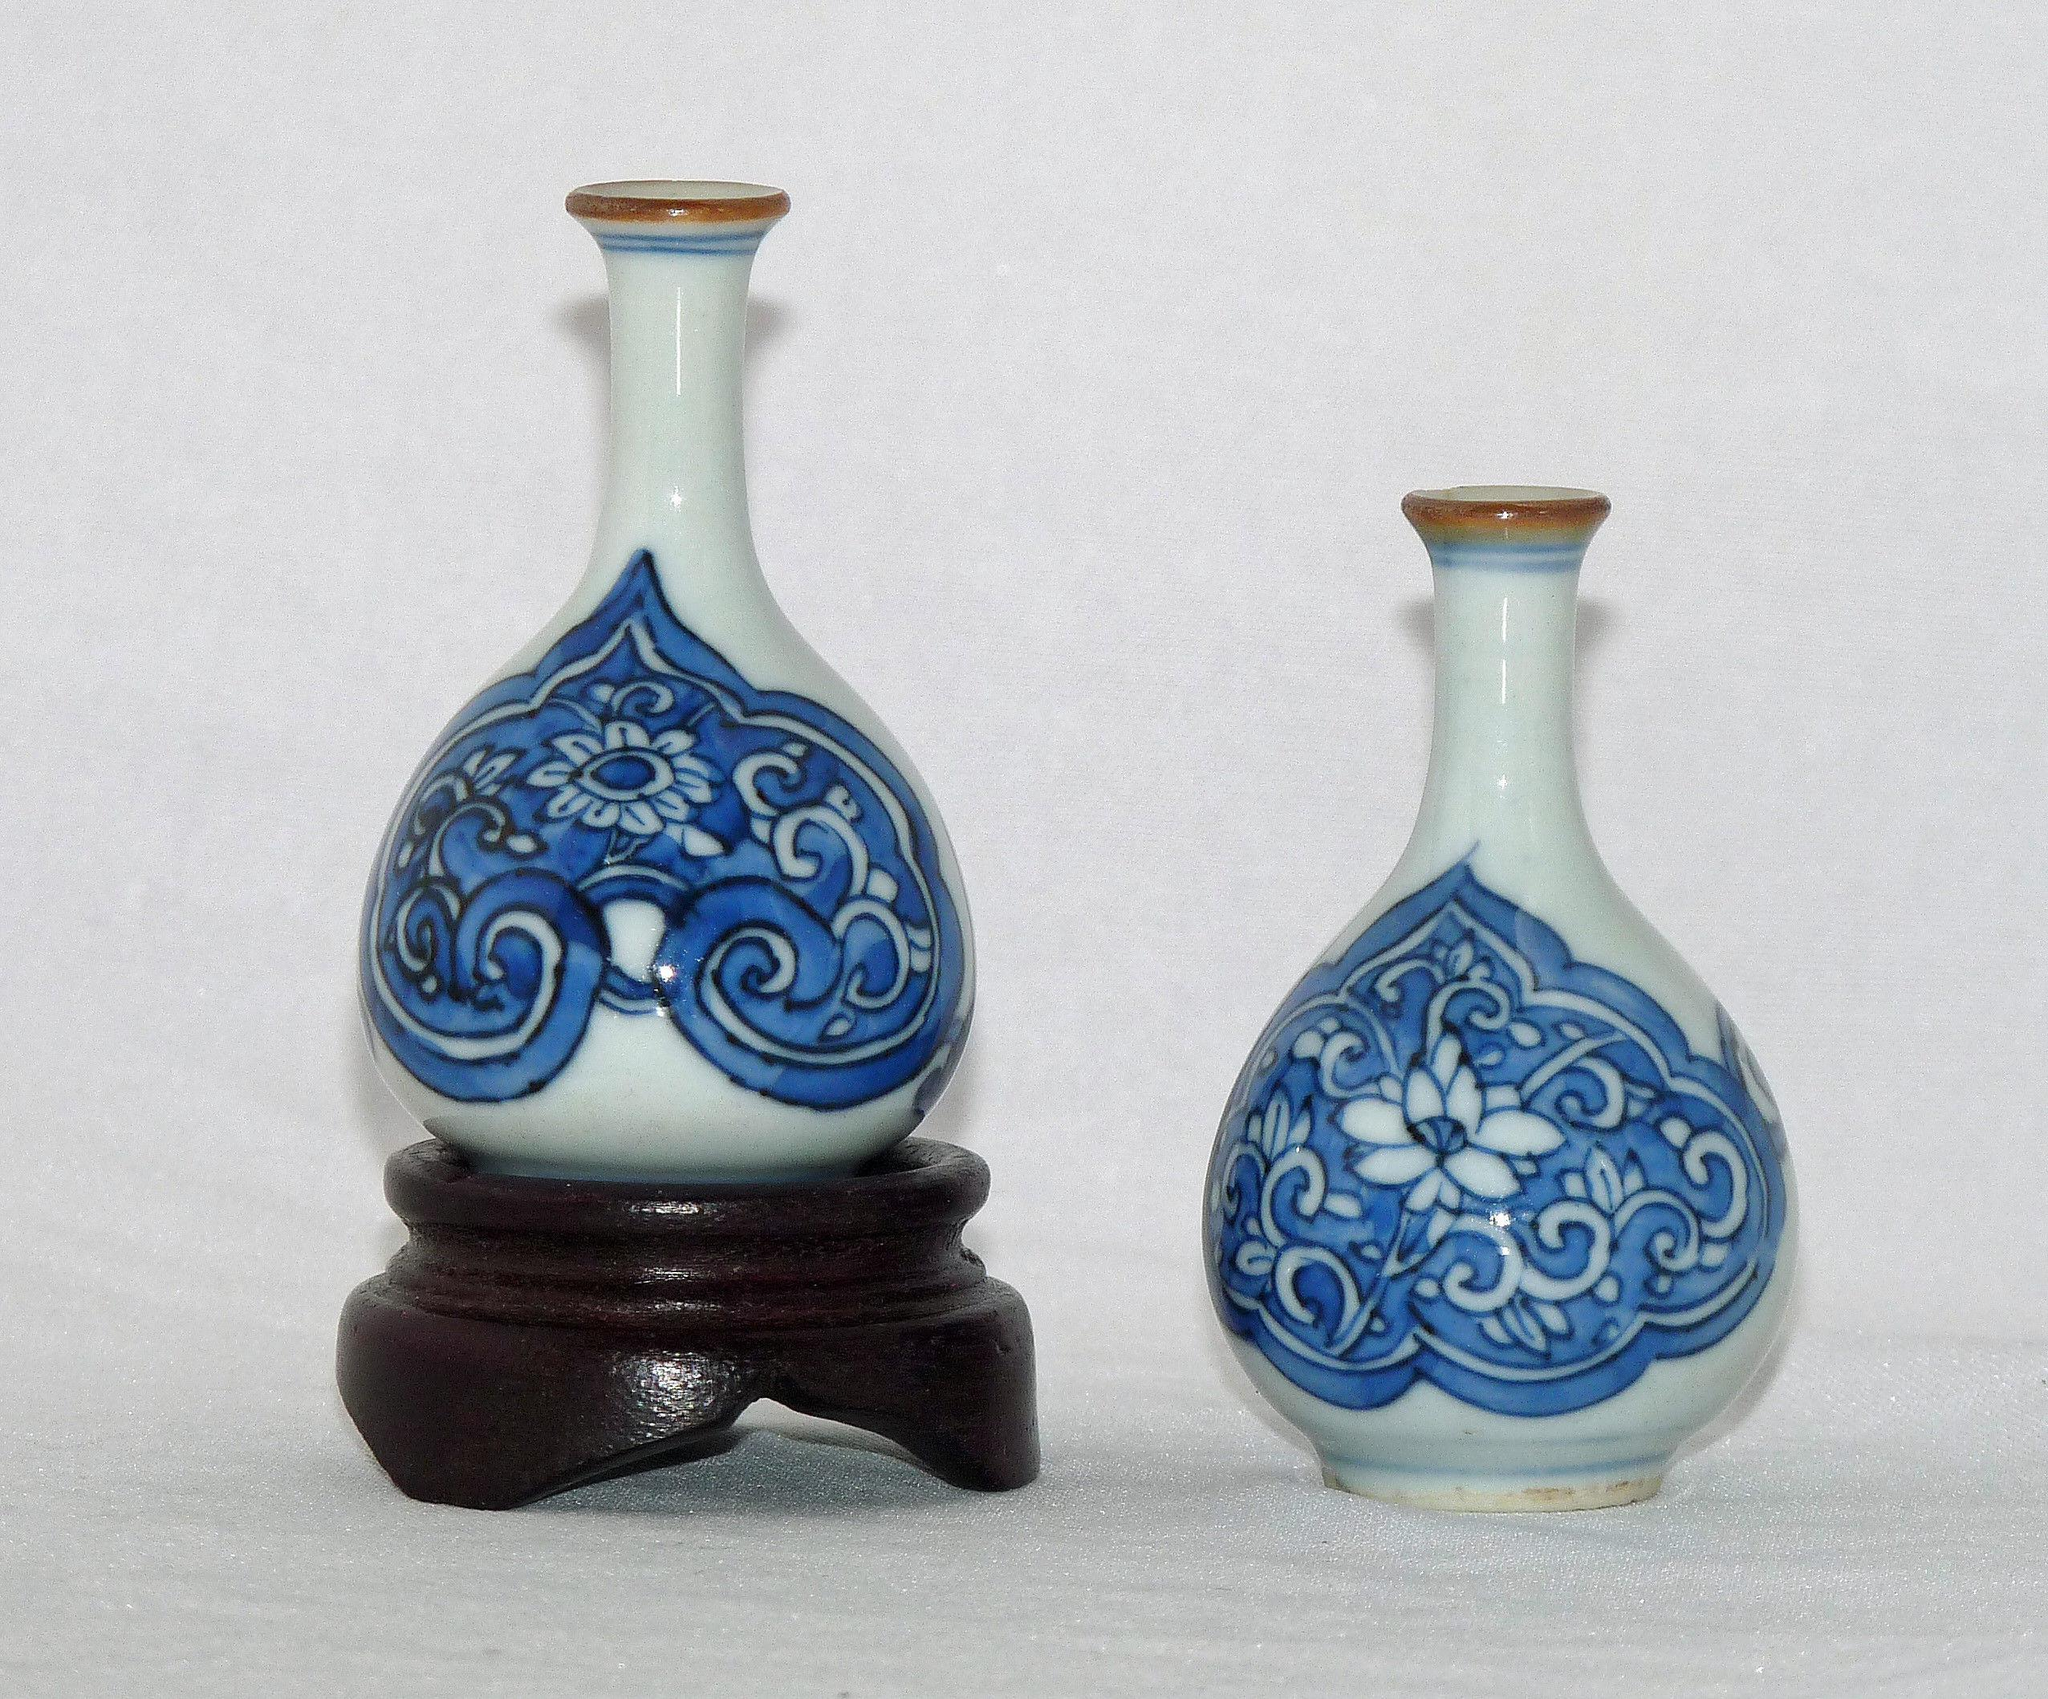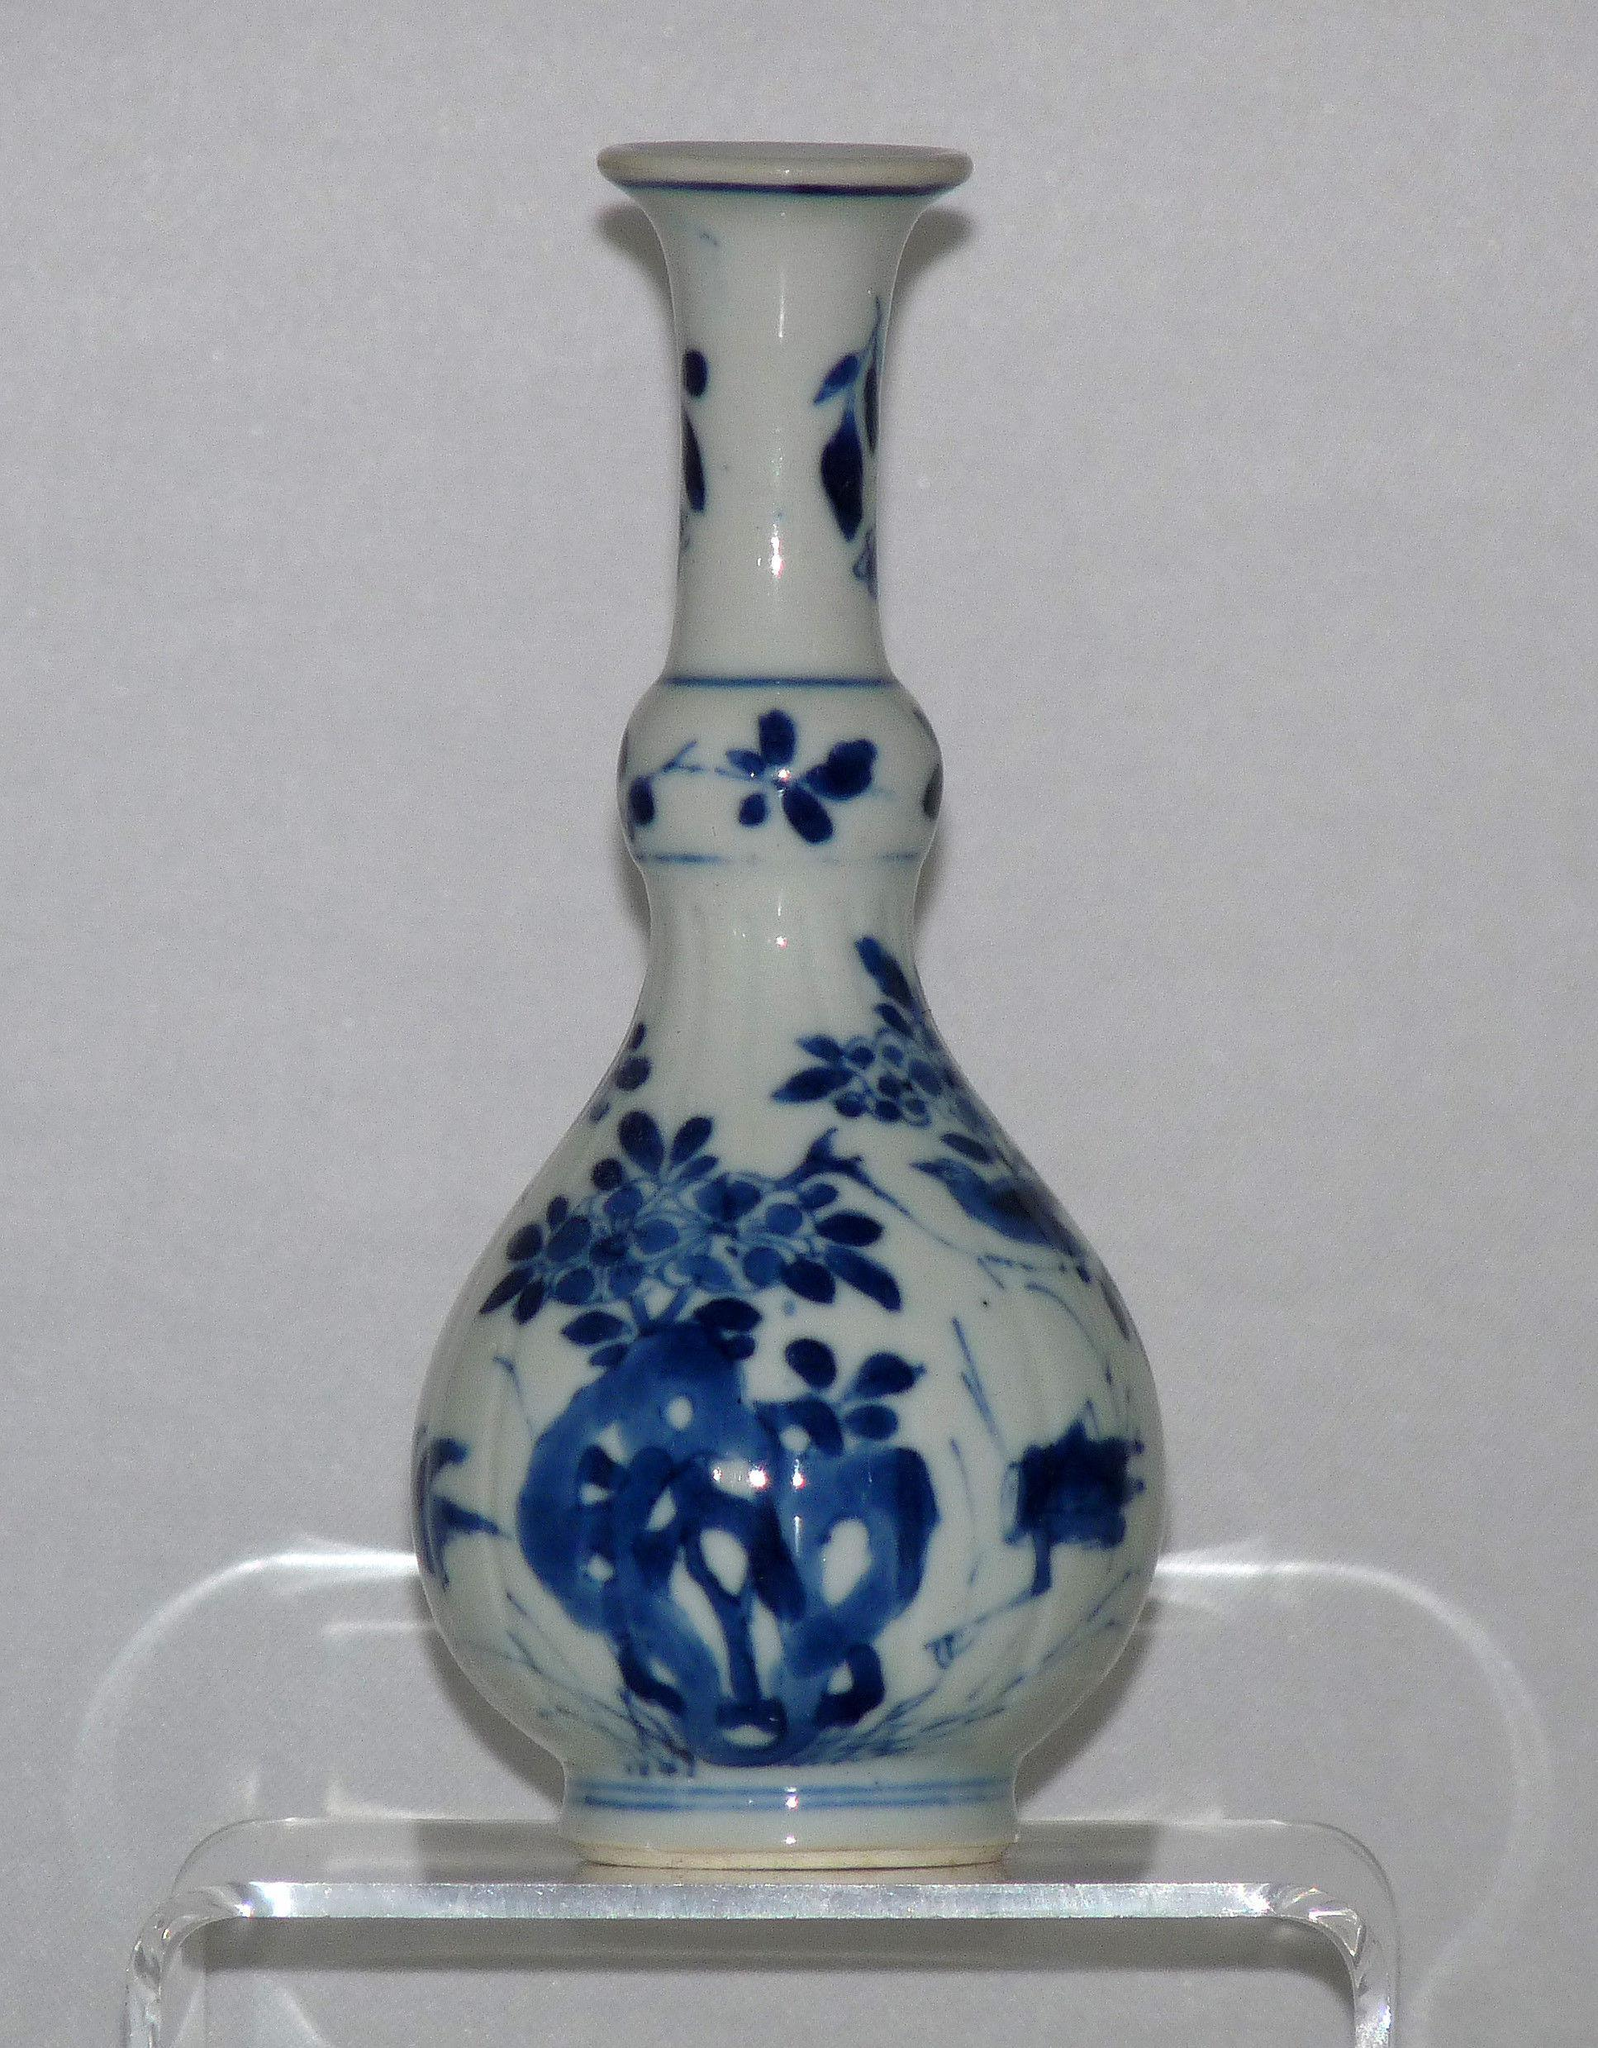The first image is the image on the left, the second image is the image on the right. Given the left and right images, does the statement "The vase in the image on the right has a bulb shaped neck." hold true? Answer yes or no. Yes. The first image is the image on the left, the second image is the image on the right. Assess this claim about the two images: "Each image contains a single white vase with blue decoration, and no vase has a cover.". Correct or not? Answer yes or no. No. 